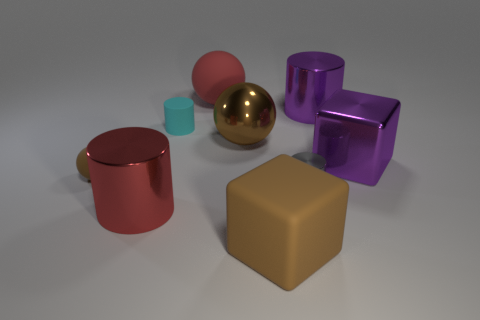What material is the red thing that is left of the big red object to the right of the red cylinder?
Offer a terse response. Metal. There is a small cyan thing; what shape is it?
Your response must be concise. Cylinder. Are there the same number of red cylinders to the right of the red rubber sphere and rubber cubes behind the tiny gray metallic cylinder?
Ensure brevity in your answer.  Yes. There is a big matte block in front of the big red sphere; is it the same color as the large shiny cylinder that is in front of the tiny brown thing?
Provide a short and direct response. No. Are there more things in front of the big brown rubber thing than brown metal objects?
Make the answer very short. No. There is a big brown thing that is made of the same material as the small cyan thing; what is its shape?
Provide a short and direct response. Cube. There is a block that is in front of the red shiny object; is its size the same as the red ball?
Make the answer very short. Yes. What shape is the big matte thing in front of the red object behind the small matte cylinder?
Offer a very short reply. Cube. What is the size of the matte object in front of the object that is on the left side of the large red cylinder?
Offer a very short reply. Large. The matte ball that is behind the small sphere is what color?
Your response must be concise. Red. 